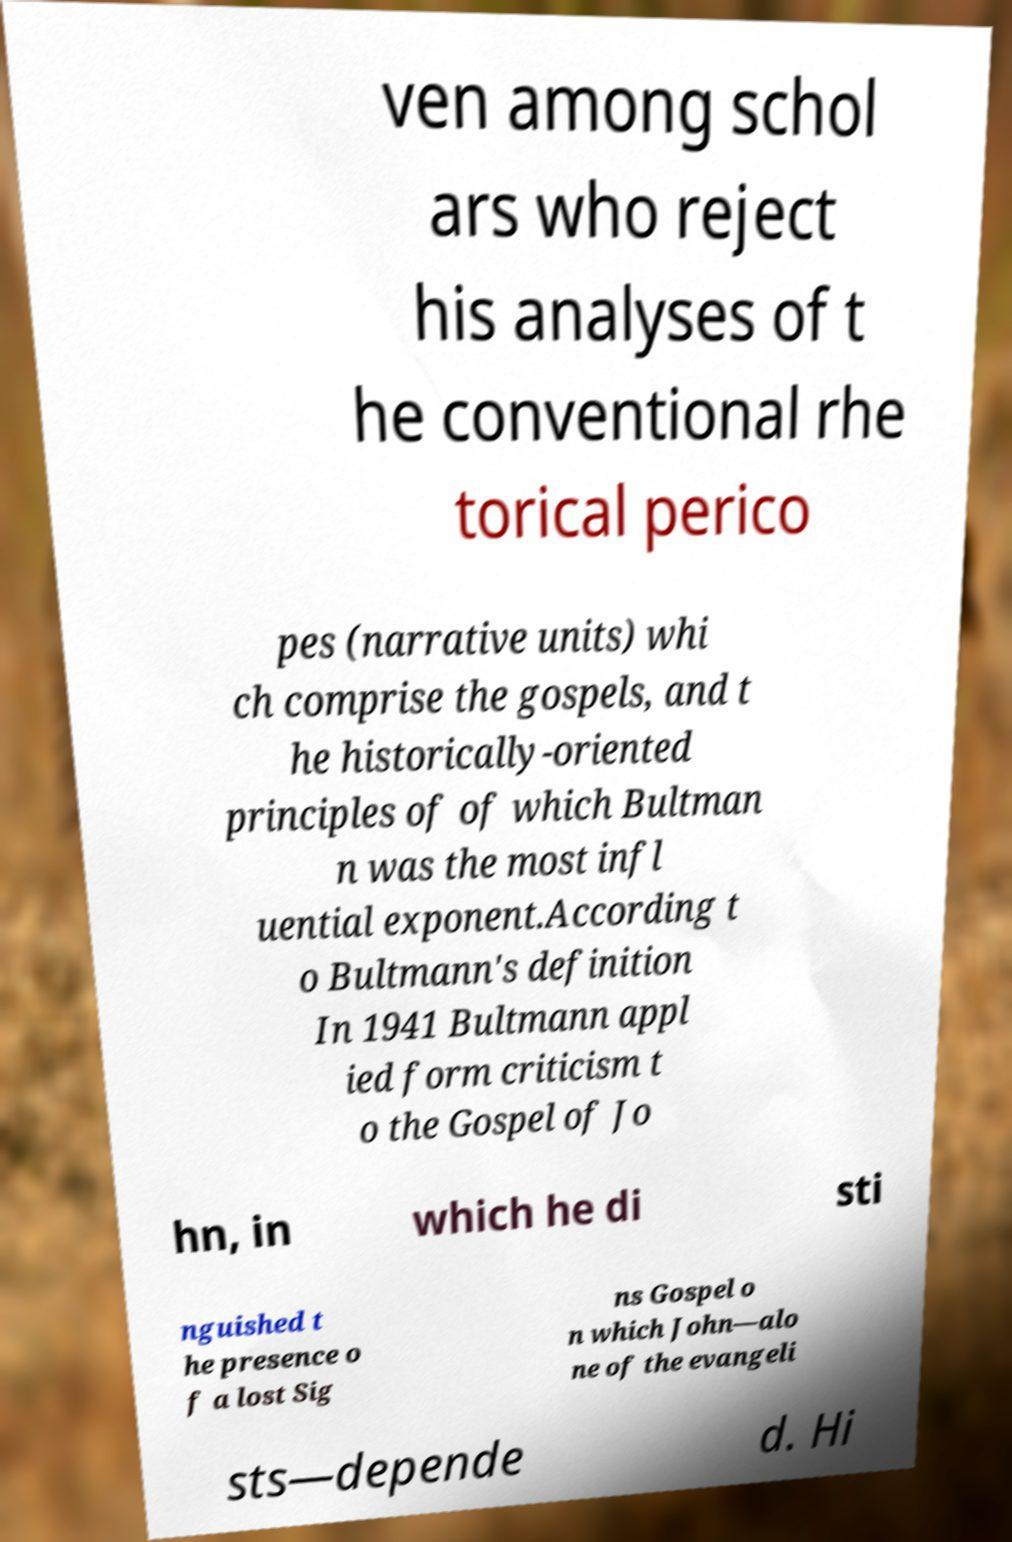Please identify and transcribe the text found in this image. ven among schol ars who reject his analyses of t he conventional rhe torical perico pes (narrative units) whi ch comprise the gospels, and t he historically-oriented principles of of which Bultman n was the most infl uential exponent.According t o Bultmann's definition In 1941 Bultmann appl ied form criticism t o the Gospel of Jo hn, in which he di sti nguished t he presence o f a lost Sig ns Gospel o n which John—alo ne of the evangeli sts—depende d. Hi 